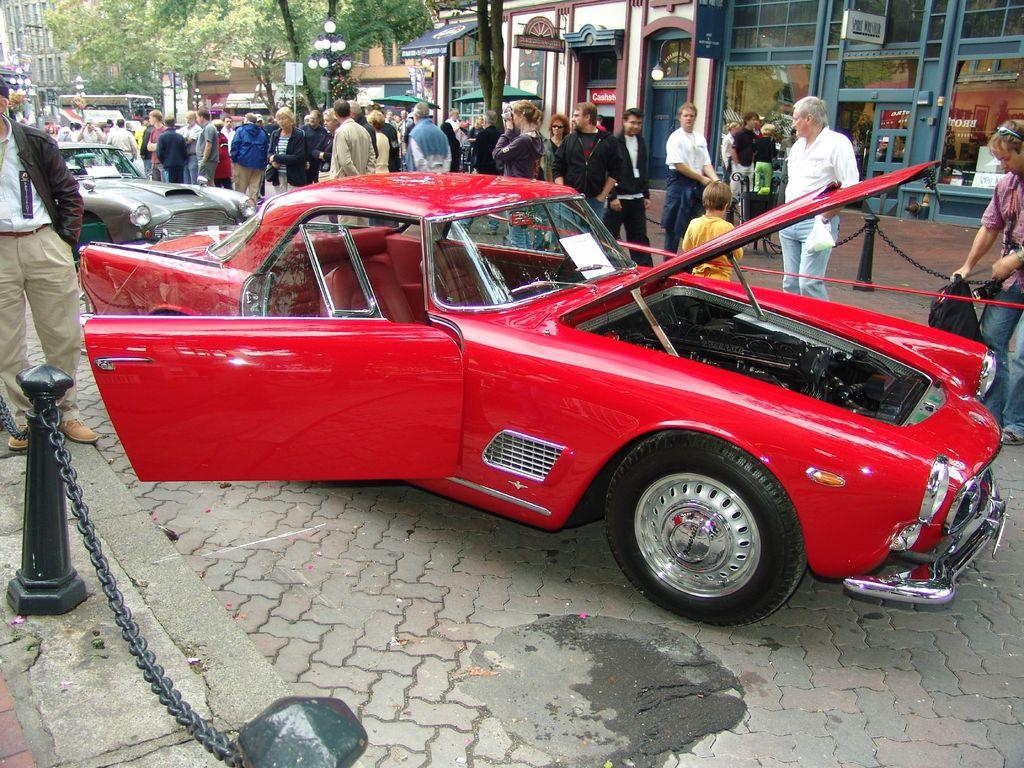What is the color of the car in the foreground of the image? The car in the foreground of the image is red. What can be seen in the background of the image? Unfortunately, the provided facts do not mention anything about the background of the image. How many people are present in the image? There are many people standing in the image. What type of lumber is being used to teach the people in the image? There is no lumber or teaching activity present in the image. What role does the porter play in the image? There is no porter present in the image. 